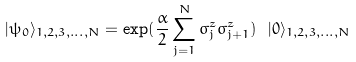<formula> <loc_0><loc_0><loc_500><loc_500>| \psi _ { 0 } \rangle _ { 1 , 2 , 3 , \dots , N } = \exp ( \frac { \alpha } { 2 } \sum _ { j = 1 } ^ { N } \sigma _ { j } ^ { z } \sigma _ { j + 1 } ^ { z } ) \ | 0 \rangle _ { 1 , 2 , 3 , \dots , N }</formula> 